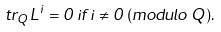Convert formula to latex. <formula><loc_0><loc_0><loc_500><loc_500>t r _ { Q } L ^ { i } = 0 \, i f \, i \ne 0 \, ( m o d u l o \, Q ) .</formula> 